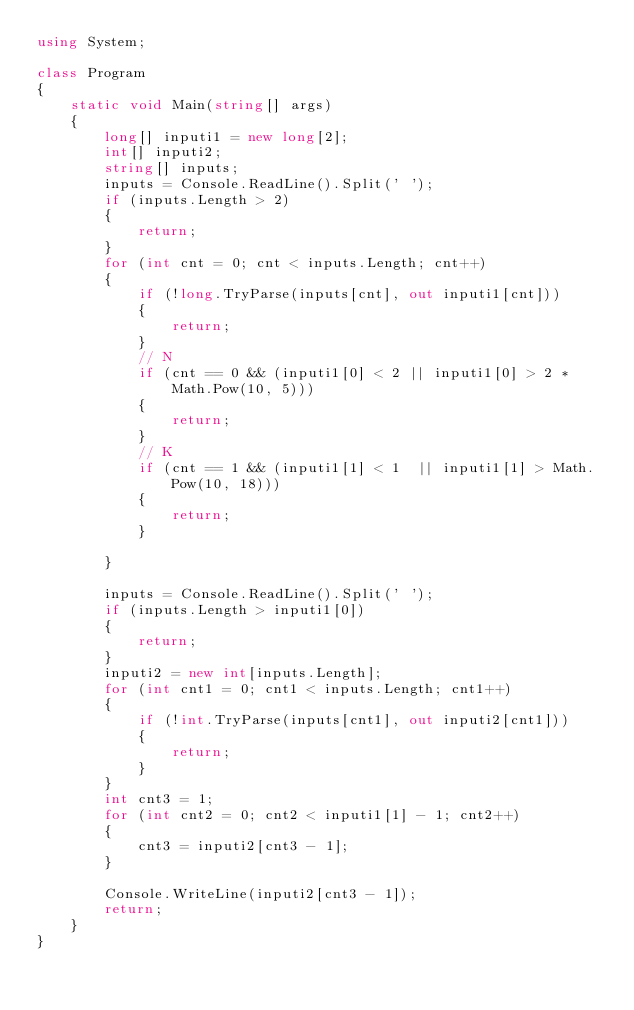Convert code to text. <code><loc_0><loc_0><loc_500><loc_500><_C#_>using System;

class Program
{
    static void Main(string[] args)
    {
        long[] inputi1 = new long[2];
        int[] inputi2;
        string[] inputs;
        inputs = Console.ReadLine().Split(' ');
        if (inputs.Length > 2)
        {
            return;
        }
        for (int cnt = 0; cnt < inputs.Length; cnt++)
        {
            if (!long.TryParse(inputs[cnt], out inputi1[cnt]))
            {
                return;
            }
            // N
            if (cnt == 0 && (inputi1[0] < 2 || inputi1[0] > 2 * Math.Pow(10, 5)))
            {
                return;
            }
            // K
            if (cnt == 1 && (inputi1[1] < 1  || inputi1[1] > Math.Pow(10, 18)))
            {
                return;
            }
            
        }

        inputs = Console.ReadLine().Split(' ');
        if (inputs.Length > inputi1[0])
        {
            return;
        }
        inputi2 = new int[inputs.Length];
        for (int cnt1 = 0; cnt1 < inputs.Length; cnt1++)
        {
            if (!int.TryParse(inputs[cnt1], out inputi2[cnt1]))
            {
                return;
            }
        }
        int cnt3 = 1;
        for (int cnt2 = 0; cnt2 < inputi1[1] - 1; cnt2++)
        {
            cnt3 = inputi2[cnt3 - 1];
        }

        Console.WriteLine(inputi2[cnt3 - 1]);
        return;
    }
}
</code> 